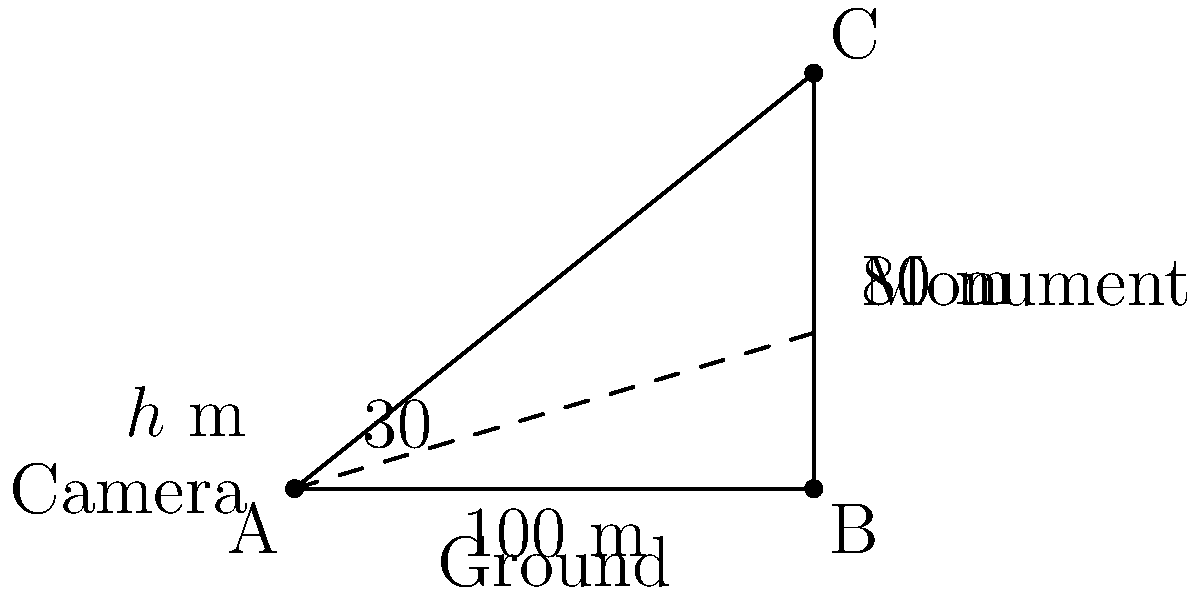As a documentary filmmaker, you're tasked with capturing footage of a historical monument. The monument is 80 meters tall and located 100 meters away from your camera position. To capture the entire monument in frame, you need to position your camera at a specific height and angle it upwards at 30°. Using trigonometry, calculate the optimal height (h) in meters at which you should position your camera. Let's approach this step-by-step:

1) First, let's identify what we know:
   - The monument is 80 meters tall
   - The camera is 100 meters away from the monument
   - The camera needs to be angled 30° upwards

2) We can use the tangent function to solve this problem. The tangent of an angle in a right triangle is the ratio of the opposite side to the adjacent side.

3) In this case:
   - The opposite side is the height difference between the top of the monument and the camera (80 - h)
   - The adjacent side is the distance from the camera to the monument (100)
   - The angle is 30°

4) We can express this as an equation:

   $$\tan(30°) = \frac{80 - h}{100}$$

5) We know that $\tan(30°) = \frac{1}{\sqrt{3}}$, so we can substitute this:

   $$\frac{1}{\sqrt{3}} = \frac{80 - h}{100}$$

6) Now, let's solve for h:

   $$100 \cdot \frac{1}{\sqrt{3}} = 80 - h$$
   
   $$\frac{100}{\sqrt{3}} = 80 - h$$
   
   $$h = 80 - \frac{100}{\sqrt{3}}$$

7) Simplify:
   
   $$h = 80 - \frac{100}{\sqrt{3}} \approx 22.25$$

Therefore, the optimal camera height is approximately 22.25 meters.
Answer: $22.25$ meters 